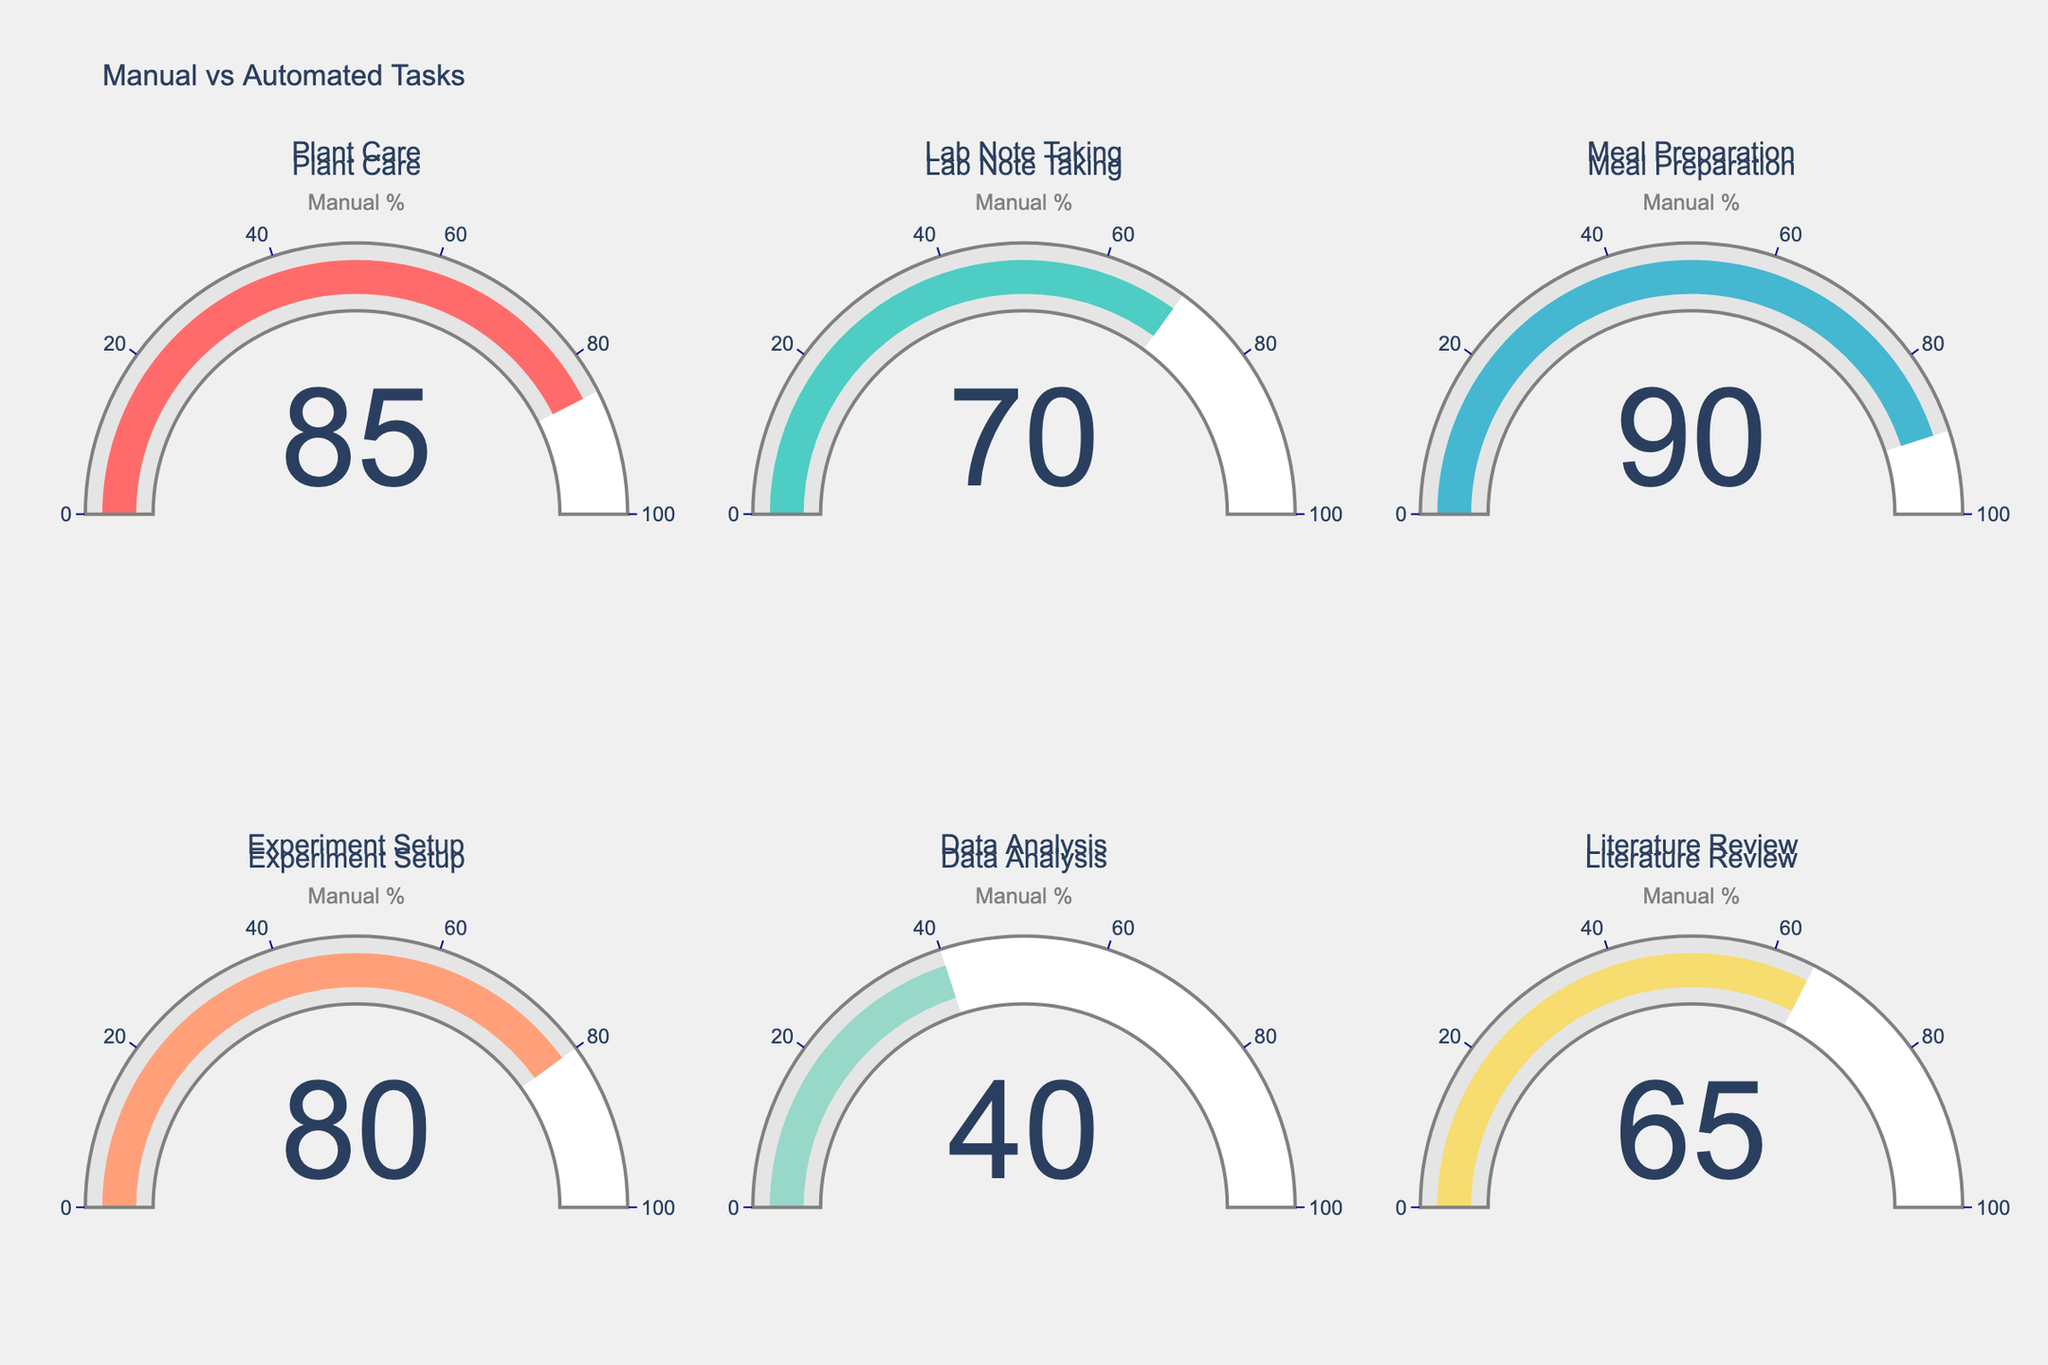What is the highest percentage of manual tasks completed? The gauge chart with the highest manual percentage shows 90%. Looking at each gauge, the 'Meal Preparation' task has the highest number at 90%.
Answer: 90% Which task has the lowest percentage of manual tasks completed? The task with the lowest percentage of manual tasks completed is 'Data Analysis'. Observing all gauges, 'Data Analysis' shows a value of 40%, which is the lowest among all tasks.
Answer: Data Analysis What is the average percentage of manual tasks completed across all tasks? To find the average, sum up the manual percentages and divide by the number of tasks: (85 + 70 + 90 + 80 + 40 + 65)/6. This results in 430/6 which equals approximately 71.67.
Answer: 71.67% By how much does 'Plant Care' exceed 'Lab Note Taking' in terms of manual percentage? 'Plant Care' has a manual percentage of 85, and 'Lab Note Taking' has 70. The difference is 85 - 70, which is 15.
Answer: 15 Which tasks have a manual percentage above 75%? Observing the gauges, the tasks with manual percentages above 75% are 'Plant Care', 'Meal Preparation', and 'Experiment Setup', showing values of 85, 90, and 80 respectively.
Answer: Plant Care, Meal Preparation, Experiment Setup Is the automated percentage for 'Data Analysis' greater than the manual percentage for 'Literature Review'? The automated percentage for 'Data Analysis' is 60, and the manual percentage for 'Literature Review' is 65. Since 60 is less than 65, the answer is no.
Answer: No What is the combined manual percentage for 'Lab Note Taking' and 'Experiment Setup'? Adding the manual percentages of 'Lab Note Taking' (70) and 'Experiment Setup' (80) results in 70 + 80 which is 150.
Answer: 150 How does the manual percentage of 'Meal Preparation' compare to 'Plant Care'? 'Meal Preparation' has a manual percentage of 90, and 'Plant Care' has 85. Comparing these, 'Meal Preparation' is 5% higher than 'Plant Care'.
Answer: Meal Preparation is 5% higher What is the median manual percentage across all tasks? First, arrange the percentages in ascending order: 40, 65, 70, 80, 85, 90. With six data points, the median is the average of the third and fourth values: (70 + 80)/2, which is 75.
Answer: 75 If the total number of tasks is considered as 100%, what percentage of tasks have a manual completion rate of 80% and above? There are 6 tasks in total. Three tasks have a manual percentage of 80 and above: 'Plant Care', 'Meal Preparation', and 'Experiment Setup'. This contributes (3/6)*100% which is 50%.
Answer: 50% 